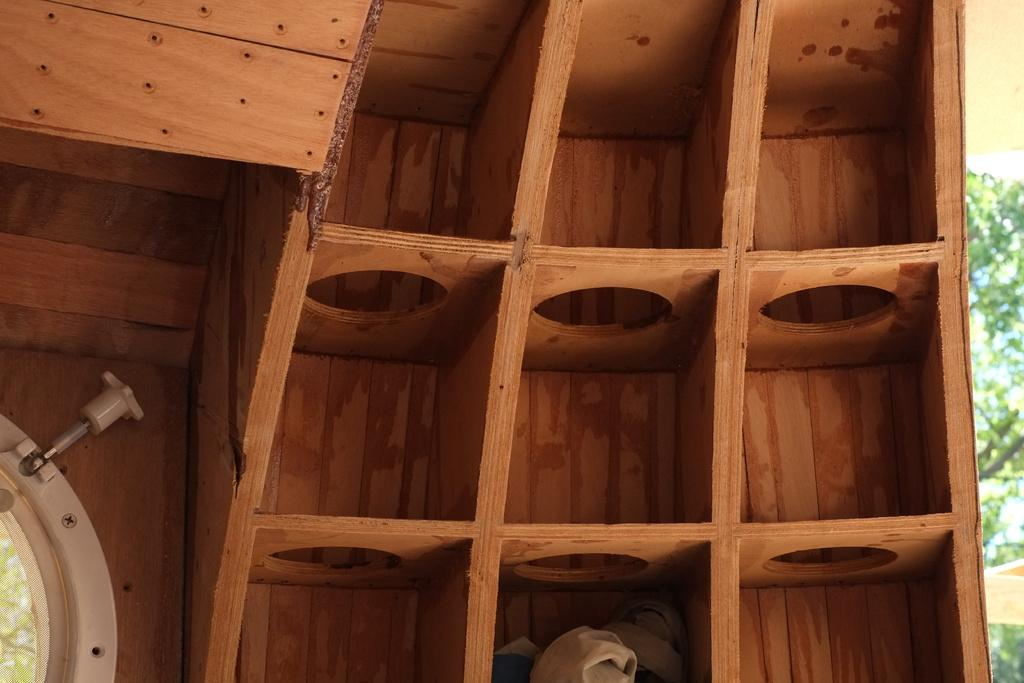What is located in the front of the image? There is a wooden stand in the front of the image. What can be seen in the background of the image? There are trees in the background of the image. What type of feast is being prepared on the wooden stand in the image? There is no indication of a feast or any food preparation in the image; it only features a wooden stand and trees in the background. 